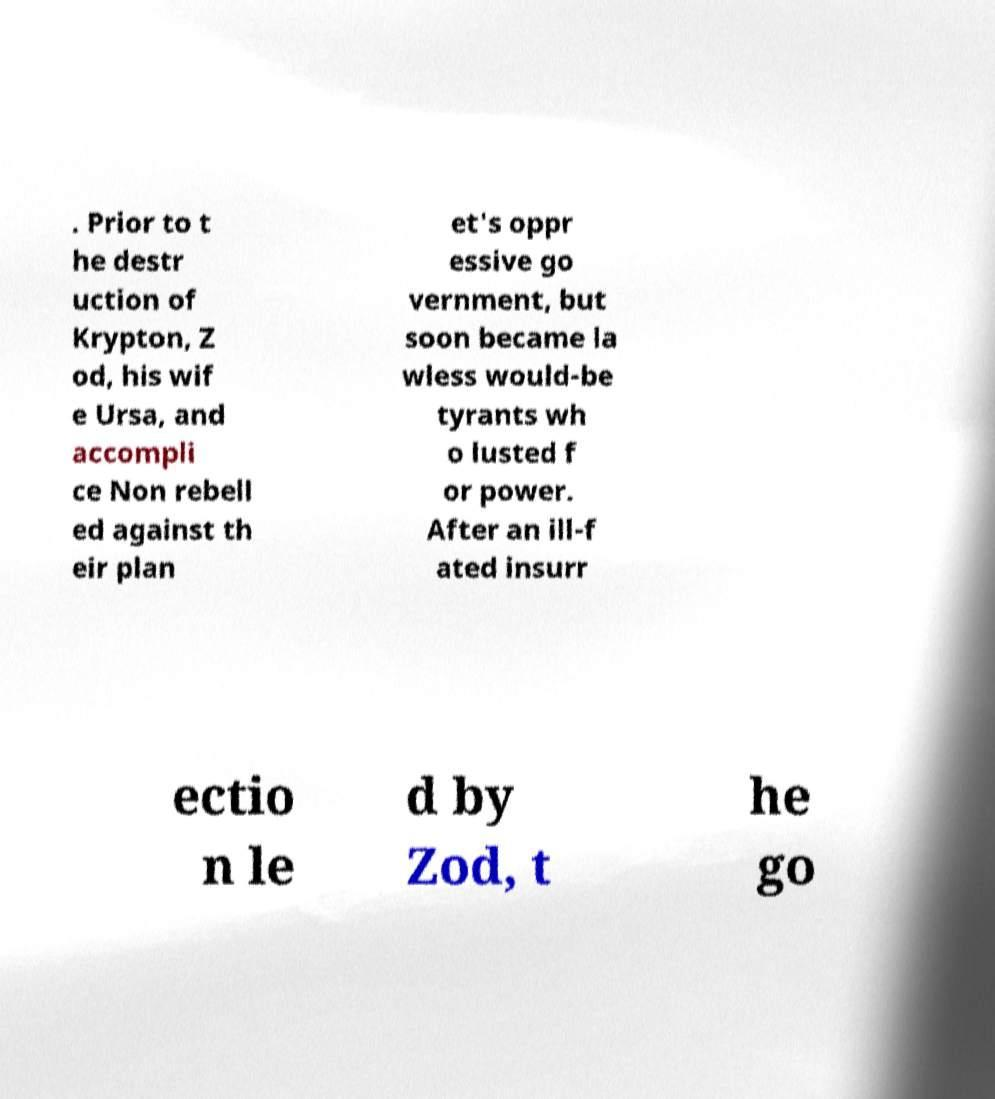Please read and relay the text visible in this image. What does it say? . Prior to t he destr uction of Krypton, Z od, his wif e Ursa, and accompli ce Non rebell ed against th eir plan et's oppr essive go vernment, but soon became la wless would-be tyrants wh o lusted f or power. After an ill-f ated insurr ectio n le d by Zod, t he go 